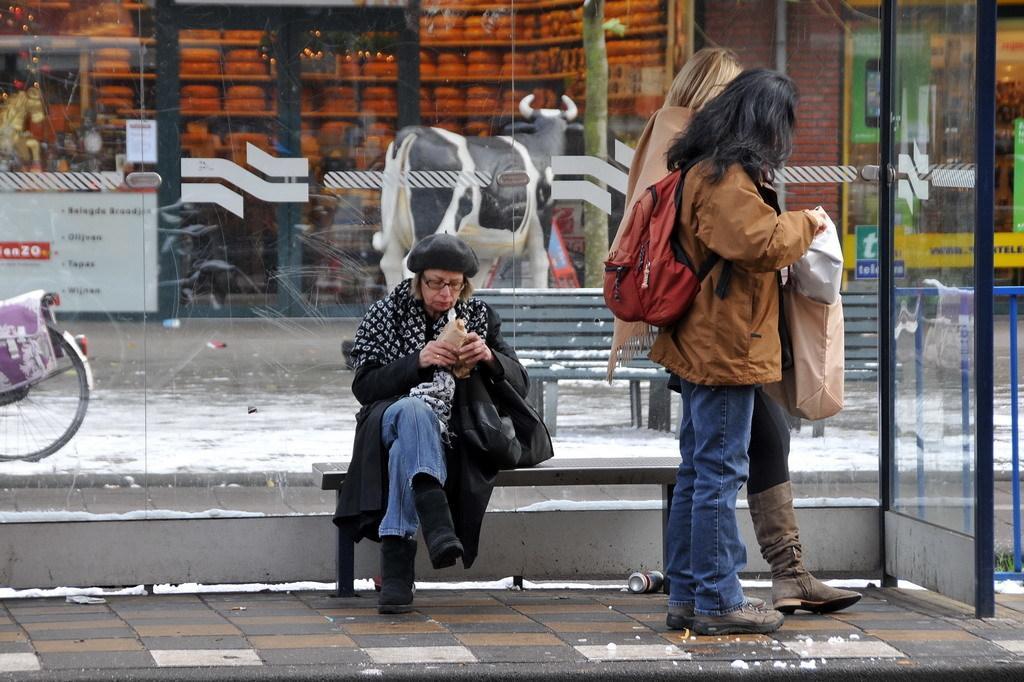Please provide a concise description of this image. In this image there are two persons standing on a footpath and a woman sitting on a bench, in the background there is a glass and bench, shops and a sculpture of cow. 